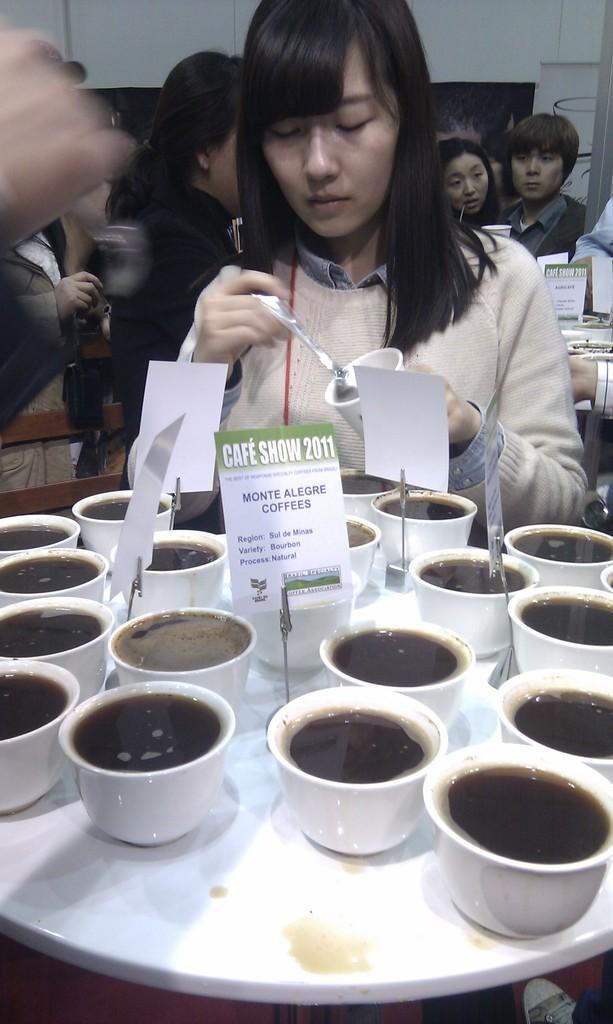What is the main piece of furniture in the image? There is a table in the image. What is placed on the table? There are many cups on the table. How many people can be seen in the image? There are many people in the image. What is the color of the background in the image? The background of the image is white. What type of apparatus is used to enhance the flavor of the cups in the image? There is no apparatus present in the image, and no mention of enhancing the flavor of the cups. 